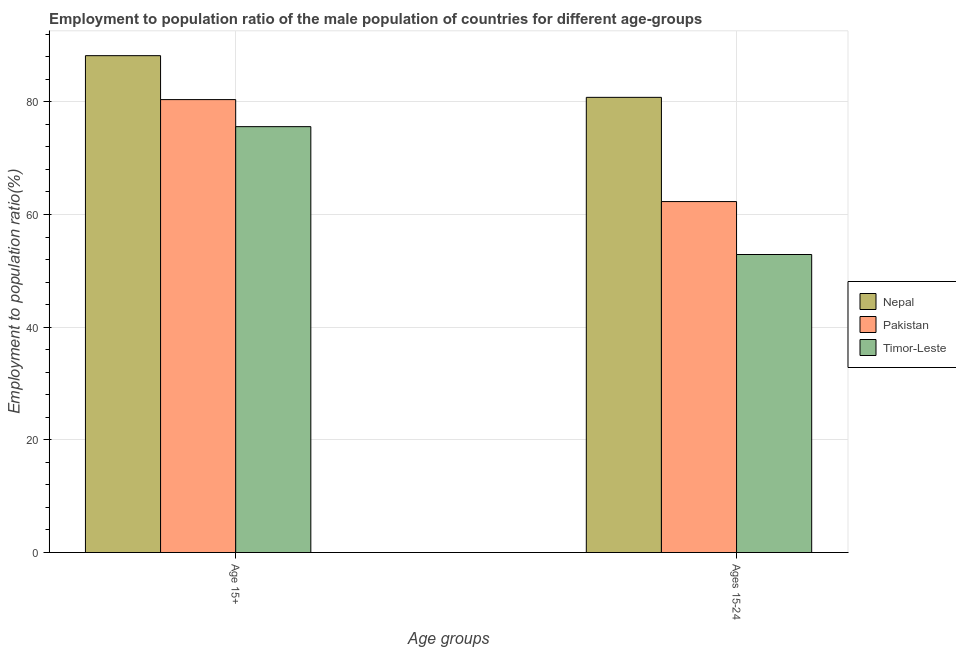How many different coloured bars are there?
Offer a very short reply. 3. How many groups of bars are there?
Your answer should be compact. 2. What is the label of the 1st group of bars from the left?
Make the answer very short. Age 15+. What is the employment to population ratio(age 15+) in Timor-Leste?
Provide a succinct answer. 75.6. Across all countries, what is the maximum employment to population ratio(age 15-24)?
Provide a succinct answer. 80.8. Across all countries, what is the minimum employment to population ratio(age 15+)?
Your answer should be very brief. 75.6. In which country was the employment to population ratio(age 15+) maximum?
Your answer should be very brief. Nepal. In which country was the employment to population ratio(age 15-24) minimum?
Keep it short and to the point. Timor-Leste. What is the total employment to population ratio(age 15+) in the graph?
Your answer should be compact. 244.2. What is the difference between the employment to population ratio(age 15-24) in Pakistan and that in Timor-Leste?
Offer a terse response. 9.4. What is the difference between the employment to population ratio(age 15-24) in Timor-Leste and the employment to population ratio(age 15+) in Nepal?
Give a very brief answer. -35.3. What is the average employment to population ratio(age 15-24) per country?
Give a very brief answer. 65.33. What is the difference between the employment to population ratio(age 15+) and employment to population ratio(age 15-24) in Timor-Leste?
Ensure brevity in your answer.  22.7. What is the ratio of the employment to population ratio(age 15+) in Nepal to that in Timor-Leste?
Keep it short and to the point. 1.17. Is the employment to population ratio(age 15-24) in Nepal less than that in Pakistan?
Your response must be concise. No. In how many countries, is the employment to population ratio(age 15+) greater than the average employment to population ratio(age 15+) taken over all countries?
Make the answer very short. 1. What does the 3rd bar from the right in Ages 15-24 represents?
Keep it short and to the point. Nepal. How many countries are there in the graph?
Ensure brevity in your answer.  3. What is the difference between two consecutive major ticks on the Y-axis?
Give a very brief answer. 20. Does the graph contain any zero values?
Offer a very short reply. No. Does the graph contain grids?
Your answer should be very brief. Yes. Where does the legend appear in the graph?
Keep it short and to the point. Center right. How are the legend labels stacked?
Give a very brief answer. Vertical. What is the title of the graph?
Ensure brevity in your answer.  Employment to population ratio of the male population of countries for different age-groups. Does "Low & middle income" appear as one of the legend labels in the graph?
Your response must be concise. No. What is the label or title of the X-axis?
Provide a short and direct response. Age groups. What is the label or title of the Y-axis?
Offer a terse response. Employment to population ratio(%). What is the Employment to population ratio(%) in Nepal in Age 15+?
Provide a succinct answer. 88.2. What is the Employment to population ratio(%) of Pakistan in Age 15+?
Provide a short and direct response. 80.4. What is the Employment to population ratio(%) of Timor-Leste in Age 15+?
Provide a short and direct response. 75.6. What is the Employment to population ratio(%) in Nepal in Ages 15-24?
Ensure brevity in your answer.  80.8. What is the Employment to population ratio(%) of Pakistan in Ages 15-24?
Offer a very short reply. 62.3. What is the Employment to population ratio(%) in Timor-Leste in Ages 15-24?
Your answer should be very brief. 52.9. Across all Age groups, what is the maximum Employment to population ratio(%) in Nepal?
Your response must be concise. 88.2. Across all Age groups, what is the maximum Employment to population ratio(%) of Pakistan?
Your response must be concise. 80.4. Across all Age groups, what is the maximum Employment to population ratio(%) of Timor-Leste?
Ensure brevity in your answer.  75.6. Across all Age groups, what is the minimum Employment to population ratio(%) of Nepal?
Keep it short and to the point. 80.8. Across all Age groups, what is the minimum Employment to population ratio(%) of Pakistan?
Your response must be concise. 62.3. Across all Age groups, what is the minimum Employment to population ratio(%) of Timor-Leste?
Give a very brief answer. 52.9. What is the total Employment to population ratio(%) of Nepal in the graph?
Offer a terse response. 169. What is the total Employment to population ratio(%) of Pakistan in the graph?
Your answer should be very brief. 142.7. What is the total Employment to population ratio(%) in Timor-Leste in the graph?
Provide a succinct answer. 128.5. What is the difference between the Employment to population ratio(%) of Pakistan in Age 15+ and that in Ages 15-24?
Your answer should be compact. 18.1. What is the difference between the Employment to population ratio(%) of Timor-Leste in Age 15+ and that in Ages 15-24?
Your answer should be compact. 22.7. What is the difference between the Employment to population ratio(%) in Nepal in Age 15+ and the Employment to population ratio(%) in Pakistan in Ages 15-24?
Make the answer very short. 25.9. What is the difference between the Employment to population ratio(%) of Nepal in Age 15+ and the Employment to population ratio(%) of Timor-Leste in Ages 15-24?
Your response must be concise. 35.3. What is the difference between the Employment to population ratio(%) of Pakistan in Age 15+ and the Employment to population ratio(%) of Timor-Leste in Ages 15-24?
Keep it short and to the point. 27.5. What is the average Employment to population ratio(%) in Nepal per Age groups?
Ensure brevity in your answer.  84.5. What is the average Employment to population ratio(%) of Pakistan per Age groups?
Offer a very short reply. 71.35. What is the average Employment to population ratio(%) in Timor-Leste per Age groups?
Make the answer very short. 64.25. What is the difference between the Employment to population ratio(%) of Nepal and Employment to population ratio(%) of Timor-Leste in Age 15+?
Keep it short and to the point. 12.6. What is the difference between the Employment to population ratio(%) of Nepal and Employment to population ratio(%) of Timor-Leste in Ages 15-24?
Keep it short and to the point. 27.9. What is the difference between the Employment to population ratio(%) in Pakistan and Employment to population ratio(%) in Timor-Leste in Ages 15-24?
Your response must be concise. 9.4. What is the ratio of the Employment to population ratio(%) in Nepal in Age 15+ to that in Ages 15-24?
Provide a succinct answer. 1.09. What is the ratio of the Employment to population ratio(%) of Pakistan in Age 15+ to that in Ages 15-24?
Provide a short and direct response. 1.29. What is the ratio of the Employment to population ratio(%) of Timor-Leste in Age 15+ to that in Ages 15-24?
Offer a terse response. 1.43. What is the difference between the highest and the second highest Employment to population ratio(%) in Nepal?
Ensure brevity in your answer.  7.4. What is the difference between the highest and the second highest Employment to population ratio(%) of Pakistan?
Offer a very short reply. 18.1. What is the difference between the highest and the second highest Employment to population ratio(%) in Timor-Leste?
Give a very brief answer. 22.7. What is the difference between the highest and the lowest Employment to population ratio(%) in Timor-Leste?
Your answer should be very brief. 22.7. 